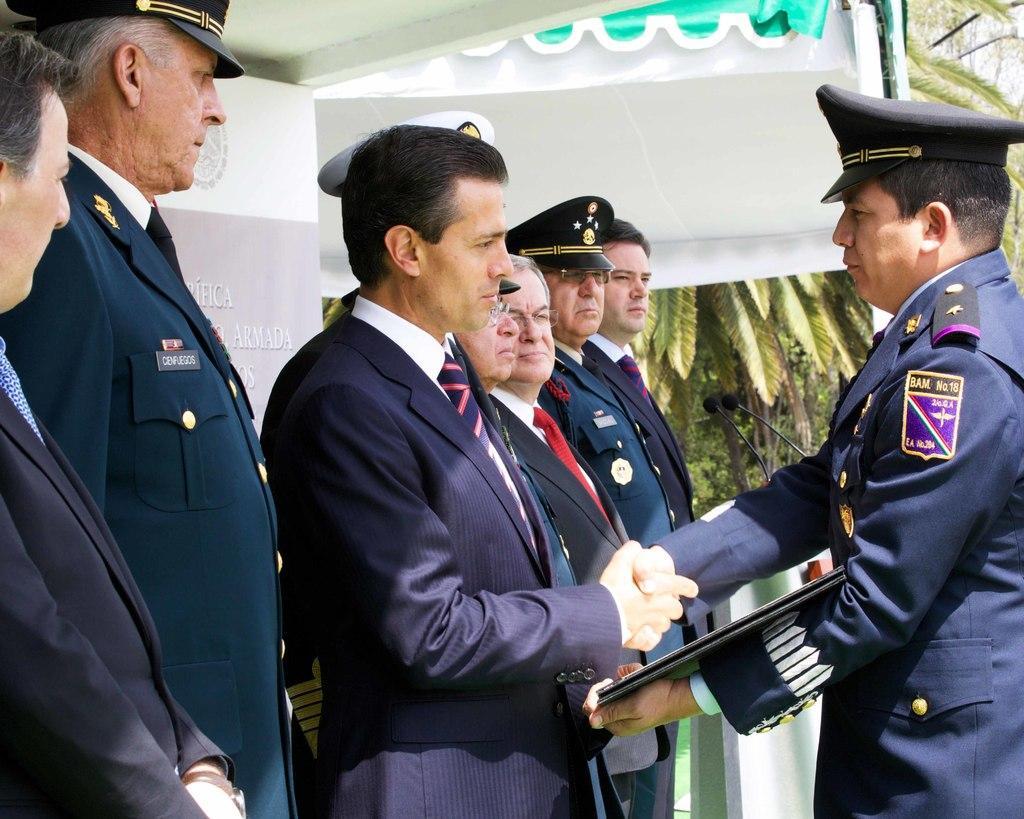Could you give a brief overview of what you see in this image? In the center of the image we can see a few people are standing and they are in different costumes. Among them, we can see a few people are wearing caps, one person is holding some object and two persons are holding hands. In the background, we can see the sky, trees, one banner with some text and a few other objects. 